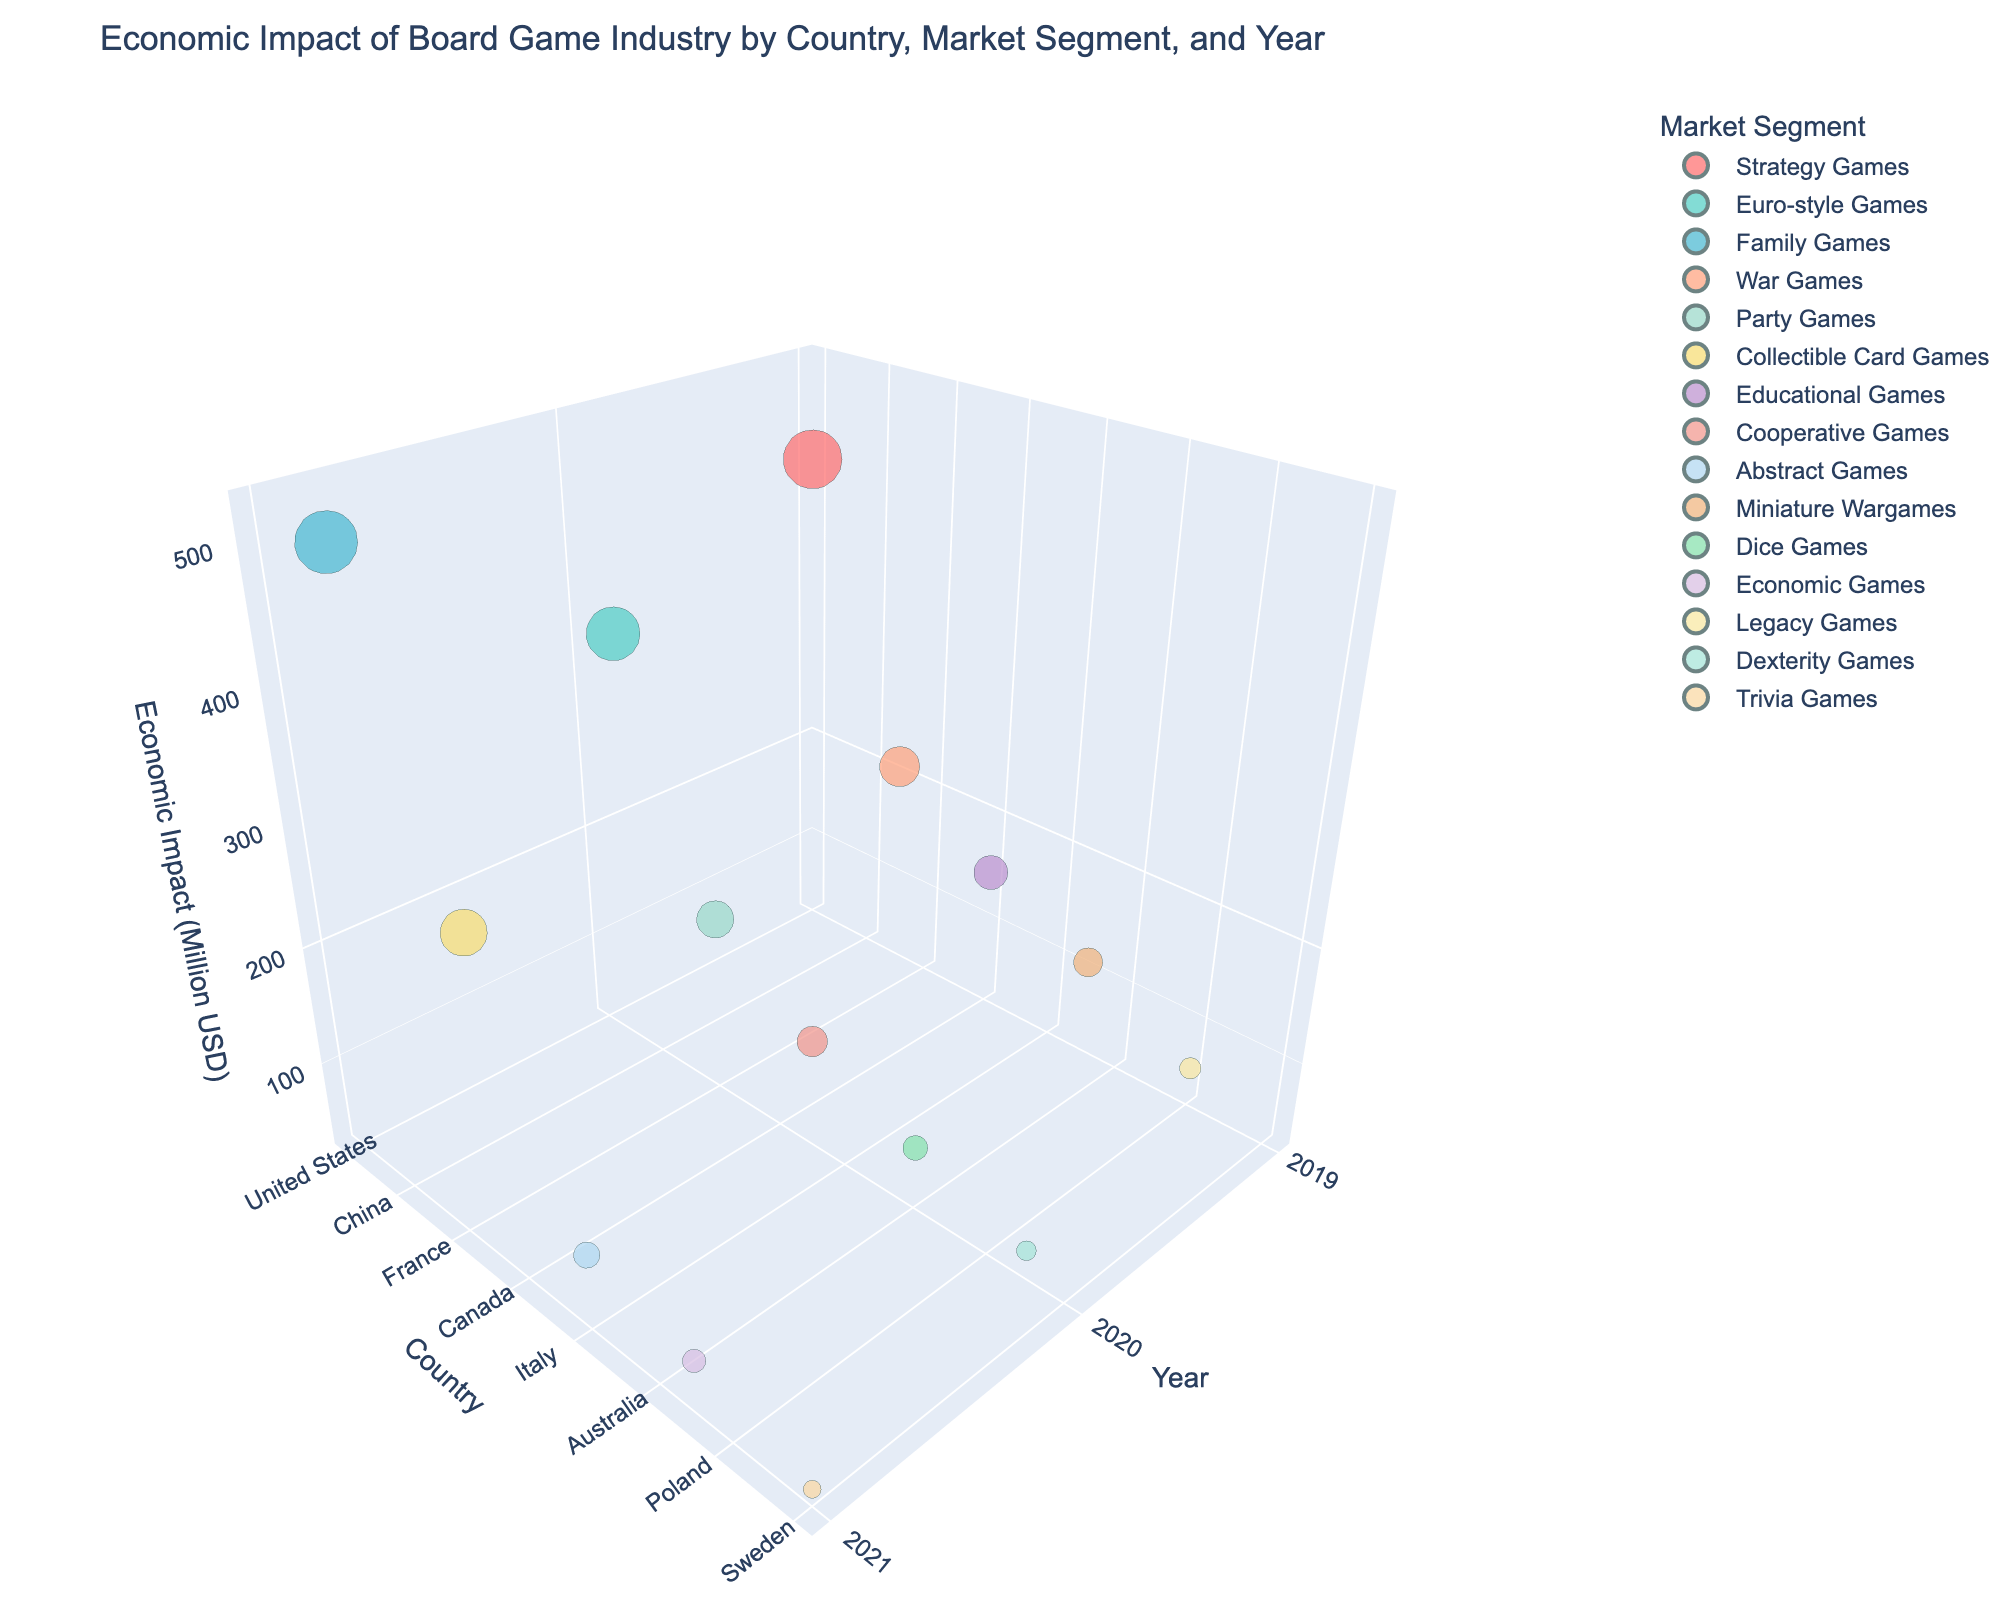How many countries are represented in the 3D bubble chart? Look at the axis labeled "Country" and count the unique country names displayed in the plot. There are 15 unique countries in the dataset.
Answer: 15 How many market segments are shown in the legend of the 3D bubble chart? Check the legend on the right-hand side of the chart. Each unique color represents a different market segment. There are 15 unique market segments.
Answer: 15 Which country had the highest economic impact in 2021? Observe the plotted bubbles, particularly those aligned with 2021 on the "Year" axis. Look for the country with the highest position on the "Economic Impact" axis in 2021, which is China with an economic impact of 520 million USD.
Answer: China What is the range of economic impacts observed in 2020? Identify the bubbles corresponding to the year 2020 on the "Year" axis and look at their values on the "Economic Impact" axis. The range is determined by the difference between the highest (Germany, 380 million USD) and the lowest (Brazil, 50 million USD) economic impacts. The range is 380 - 50 = 330 million USD.
Answer: 330 million USD Which market segment in the chart has the largest bubble size, and what country does it correspond to? Focus on the size of the bubbles, which represent the "Market Share (%)". The largest bubble size corresponds to the market segment with the highest percentage. The largest bubble in the chart represents "Family Games" in China with a market share of 17.6%.
Answer: Family Games, China Compare the economic impact of board games in Germany in 2020 and France in 2020. Which country had a higher impact and by how much? Look at the bubbles for Germany and France in 2020. Germany has an economic impact of 380 million USD, while France has 180 million USD. Calculate the difference: 380 - 180 = 200 million USD. Germany had a higher impact by 200 million USD.
Answer: Germany by 200 million USD What is the average economic impact for the countries shown in 2021? Identify the economic impacts for countries in 2021: China (520), Japan (290), Italy (90), Netherlands (70), and Sweden (40). Sum these values: 520 + 290 + 90 + 70 + 40 = 1010. There are 5 countries, so the average is 1010 / 5 = 202 million USD.
Answer: 202 million USD Which country had the smallest market share in 2019, and what was the economic impact for that country? Look at the bubbles for 2019 and check their sizes for the smallest. Poland represents the smallest market share in 2019 (2.0%), which corresponds to an economic impact of 60 million USD.
Answer: Poland, 60 million USD How many market segments had an economic impact greater than 100 million USD in 2019? Examine the bubbles aligned with 2019. Count the bubbles positioned above 100 million USD on the "Economic Impact" axis: United States (450), United Kingdom (210), South Korea (110). There are 3 such market segments.
Answer: 3 